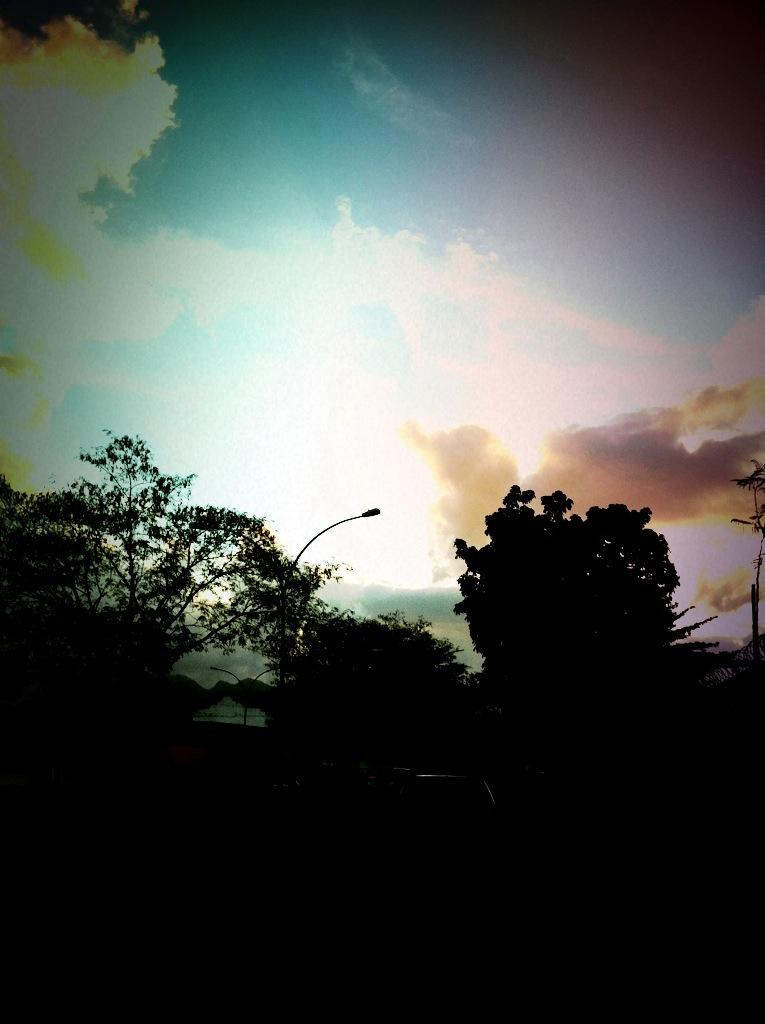What type of lighting can be seen in the image? There are street lights in the image. What other objects are present in the image? There are trees in the image. What can be seen in the background of the image? The sky is visible in the background of the image. What type of thread is used to create the mask in the image? There is no mask present in the image, so there is no thread used for it. What kind of stone can be seen in the image? There is no stone visible in the image; it features street lights and trees. 